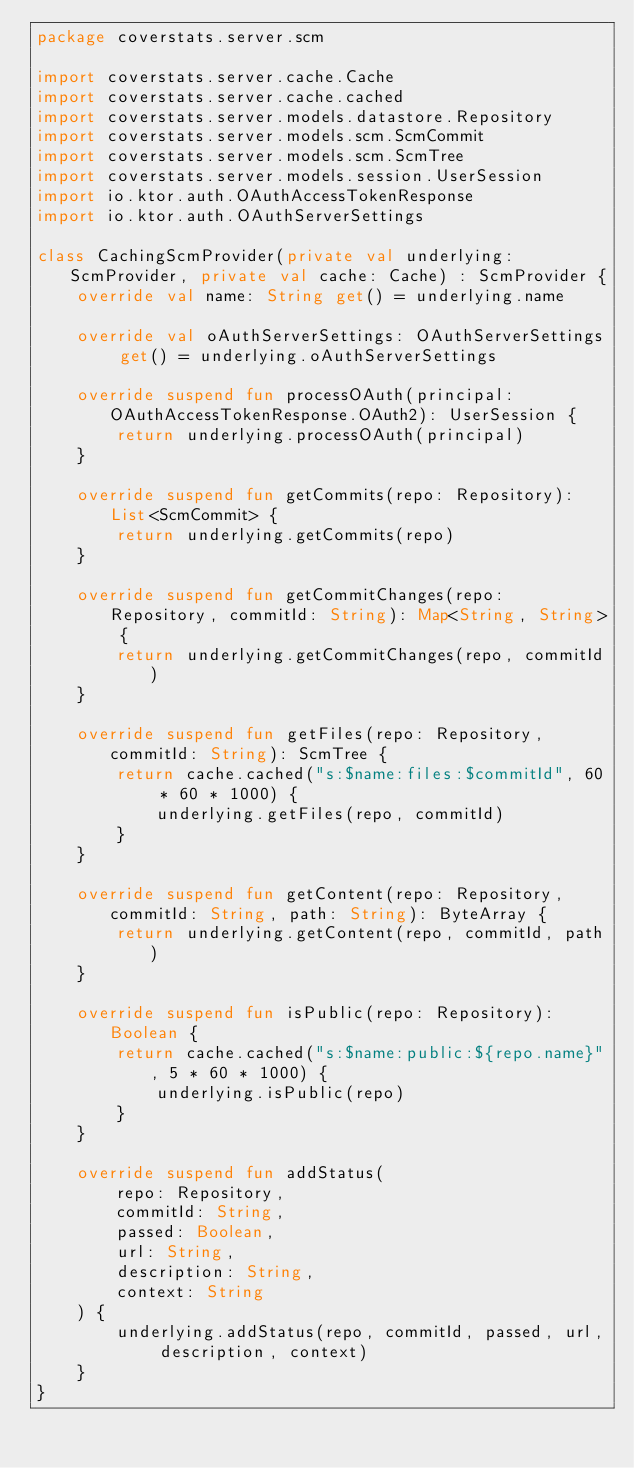<code> <loc_0><loc_0><loc_500><loc_500><_Kotlin_>package coverstats.server.scm

import coverstats.server.cache.Cache
import coverstats.server.cache.cached
import coverstats.server.models.datastore.Repository
import coverstats.server.models.scm.ScmCommit
import coverstats.server.models.scm.ScmTree
import coverstats.server.models.session.UserSession
import io.ktor.auth.OAuthAccessTokenResponse
import io.ktor.auth.OAuthServerSettings

class CachingScmProvider(private val underlying: ScmProvider, private val cache: Cache) : ScmProvider {
    override val name: String get() = underlying.name

    override val oAuthServerSettings: OAuthServerSettings get() = underlying.oAuthServerSettings

    override suspend fun processOAuth(principal: OAuthAccessTokenResponse.OAuth2): UserSession {
        return underlying.processOAuth(principal)
    }

    override suspend fun getCommits(repo: Repository): List<ScmCommit> {
        return underlying.getCommits(repo)
    }

    override suspend fun getCommitChanges(repo: Repository, commitId: String): Map<String, String> {
        return underlying.getCommitChanges(repo, commitId)
    }

    override suspend fun getFiles(repo: Repository, commitId: String): ScmTree {
        return cache.cached("s:$name:files:$commitId", 60 * 60 * 1000) {
            underlying.getFiles(repo, commitId)
        }
    }

    override suspend fun getContent(repo: Repository, commitId: String, path: String): ByteArray {
        return underlying.getContent(repo, commitId, path)
    }

    override suspend fun isPublic(repo: Repository): Boolean {
        return cache.cached("s:$name:public:${repo.name}", 5 * 60 * 1000) {
            underlying.isPublic(repo)
        }
    }

    override suspend fun addStatus(
        repo: Repository,
        commitId: String,
        passed: Boolean,
        url: String,
        description: String,
        context: String
    ) {
        underlying.addStatus(repo, commitId, passed, url, description, context)
    }
}</code> 